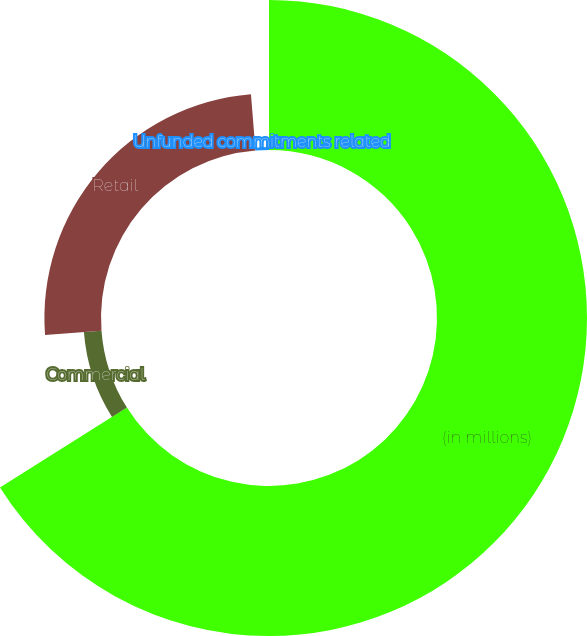Convert chart. <chart><loc_0><loc_0><loc_500><loc_500><pie_chart><fcel>(in millions)<fcel>Commercial<fcel>Retail<fcel>Unfunded commitments related<nl><fcel>66.05%<fcel>7.75%<fcel>24.92%<fcel>1.28%<nl></chart> 